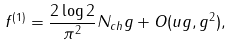<formula> <loc_0><loc_0><loc_500><loc_500>f ^ { ( 1 ) } = \frac { 2 \log 2 } { \pi ^ { 2 } } N _ { c h } g + O ( u g , g ^ { 2 } ) ,</formula> 